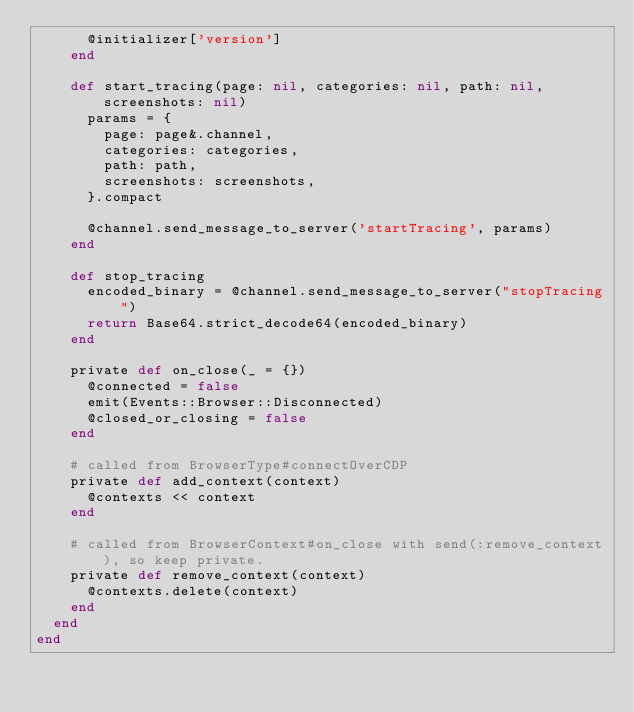Convert code to text. <code><loc_0><loc_0><loc_500><loc_500><_Ruby_>      @initializer['version']
    end

    def start_tracing(page: nil, categories: nil, path: nil, screenshots: nil)
      params = {
        page: page&.channel,
        categories: categories,
        path: path,
        screenshots: screenshots,
      }.compact

      @channel.send_message_to_server('startTracing', params)
    end

    def stop_tracing
      encoded_binary = @channel.send_message_to_server("stopTracing")
      return Base64.strict_decode64(encoded_binary)
    end

    private def on_close(_ = {})
      @connected = false
      emit(Events::Browser::Disconnected)
      @closed_or_closing = false
    end

    # called from BrowserType#connectOverCDP
    private def add_context(context)
      @contexts << context
    end

    # called from BrowserContext#on_close with send(:remove_context), so keep private.
    private def remove_context(context)
      @contexts.delete(context)
    end
  end
end
</code> 